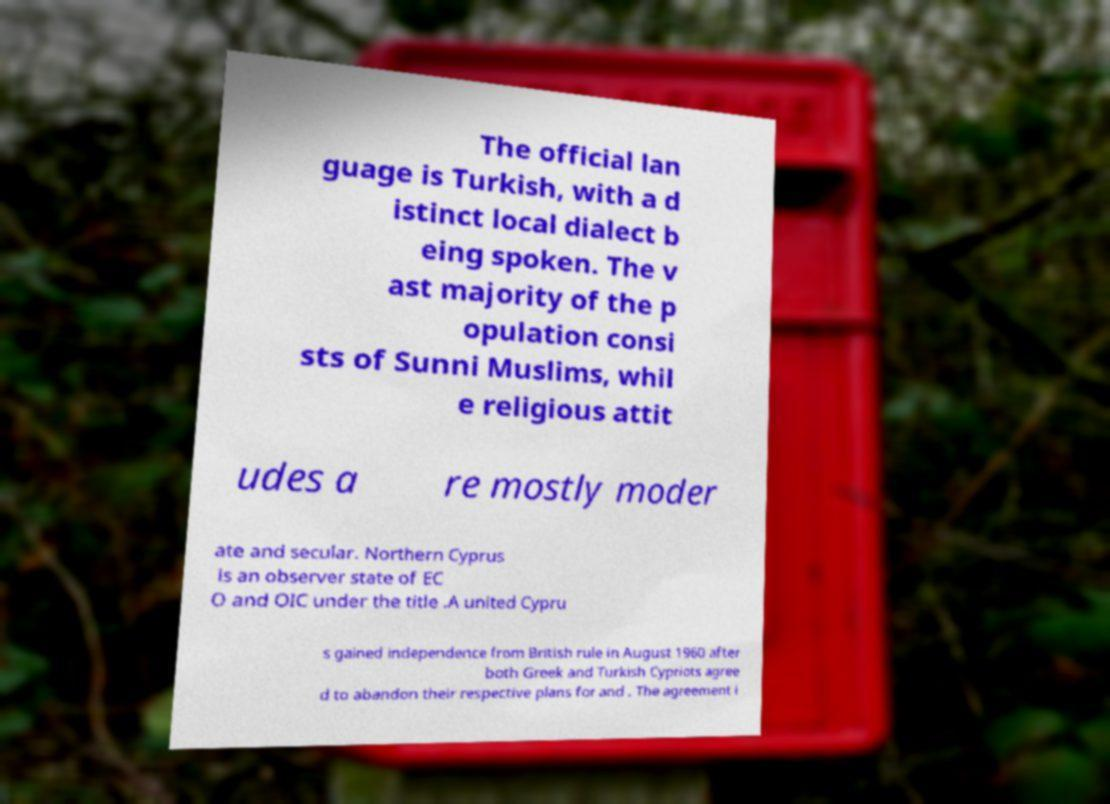For documentation purposes, I need the text within this image transcribed. Could you provide that? The official lan guage is Turkish, with a d istinct local dialect b eing spoken. The v ast majority of the p opulation consi sts of Sunni Muslims, whil e religious attit udes a re mostly moder ate and secular. Northern Cyprus is an observer state of EC O and OIC under the title .A united Cypru s gained independence from British rule in August 1960 after both Greek and Turkish Cypriots agree d to abandon their respective plans for and . The agreement i 